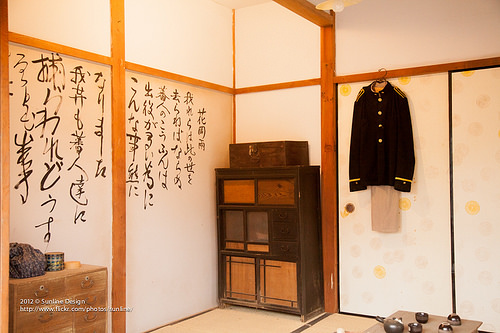<image>
Is the coat in the cabinet? No. The coat is not contained within the cabinet. These objects have a different spatial relationship. 